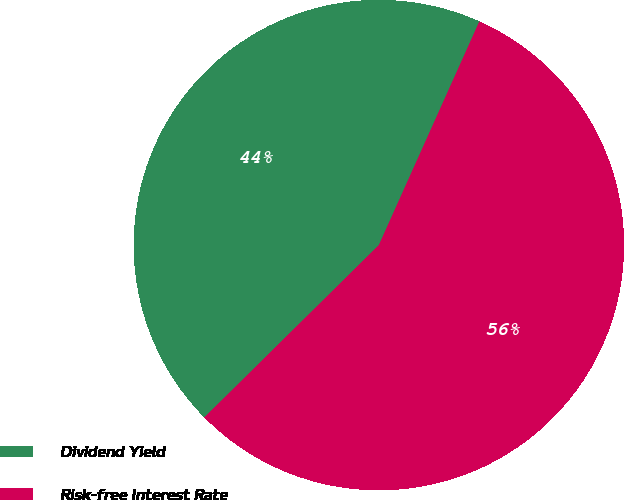<chart> <loc_0><loc_0><loc_500><loc_500><pie_chart><fcel>Dividend Yield<fcel>Risk-free Interest Rate<nl><fcel>44.12%<fcel>55.88%<nl></chart> 